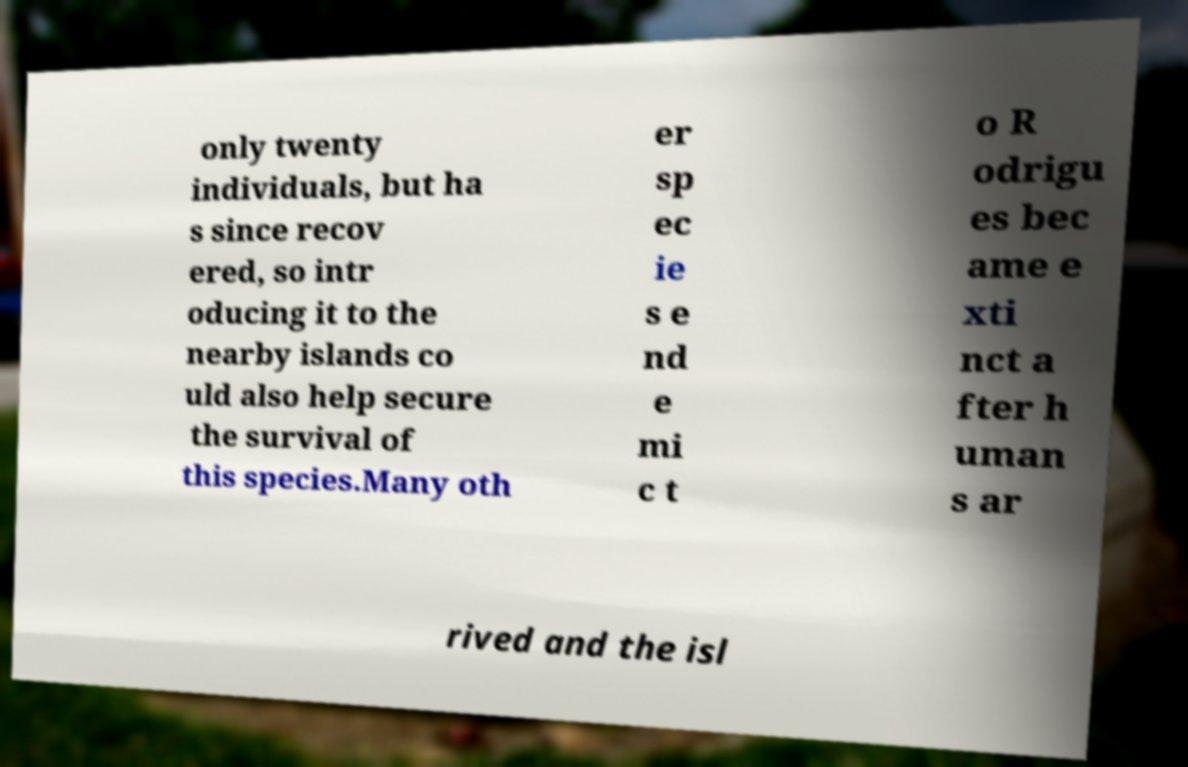What messages or text are displayed in this image? I need them in a readable, typed format. only twenty individuals, but ha s since recov ered, so intr oducing it to the nearby islands co uld also help secure the survival of this species.Many oth er sp ec ie s e nd e mi c t o R odrigu es bec ame e xti nct a fter h uman s ar rived and the isl 